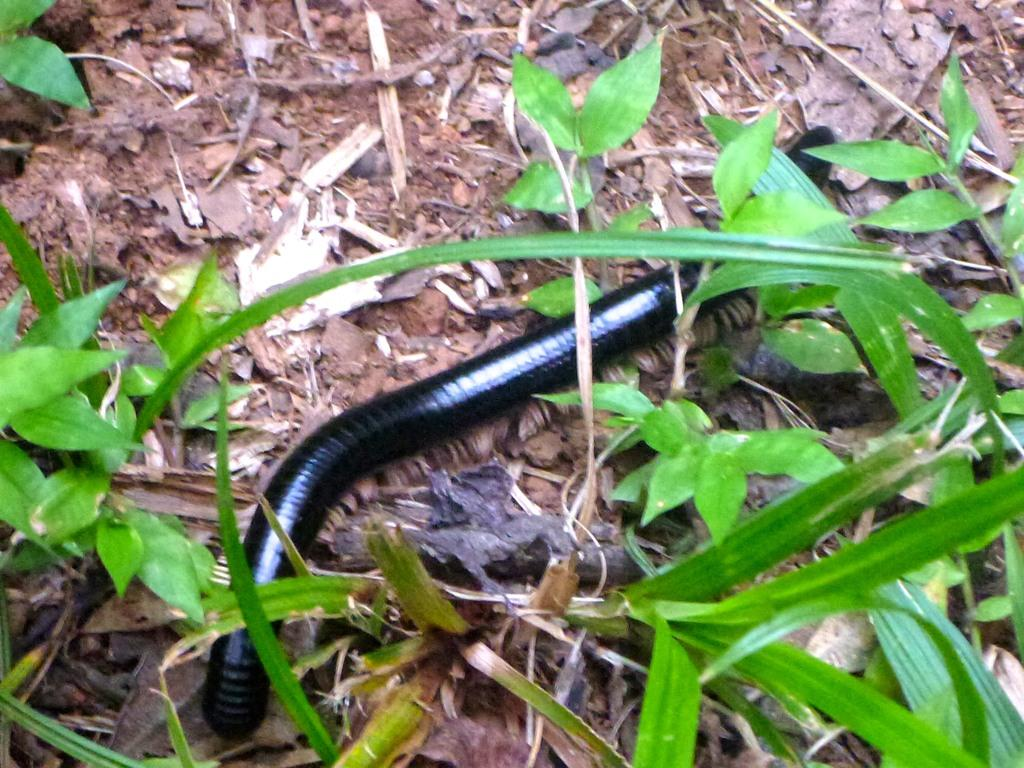What type of living organisms can be seen in the image? Plants can be seen in the image. What other living organism is present in the image? There is a black color insect in the image. What can be found on the ground in the image? There are objects on the ground in the image. How does the home in the image twist around? There is no home present in the image, so it cannot be twisted. 